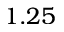Convert formula to latex. <formula><loc_0><loc_0><loc_500><loc_500>1 . 2 5</formula> 